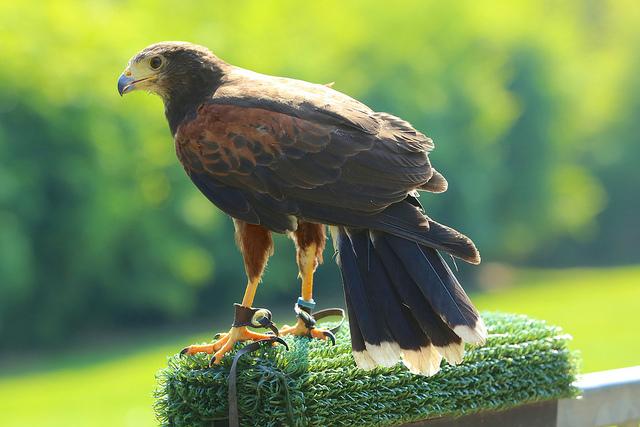Is the bird tethered?
Be succinct. Yes. Is its perch real grass?
Concise answer only. No. What time of day is it?
Short answer required. Daytime. 